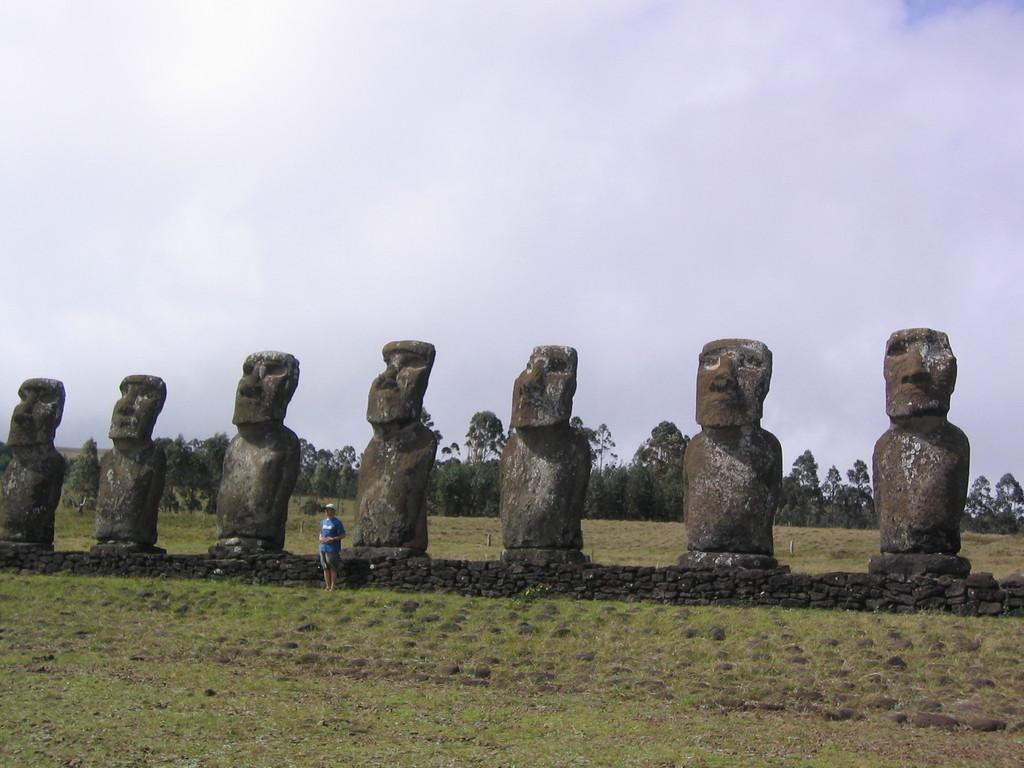Please provide a concise description of this image. In this image there is a grassland, in the background there are sculptures, near the sculptures a man standing and there are trees, and the sky. 